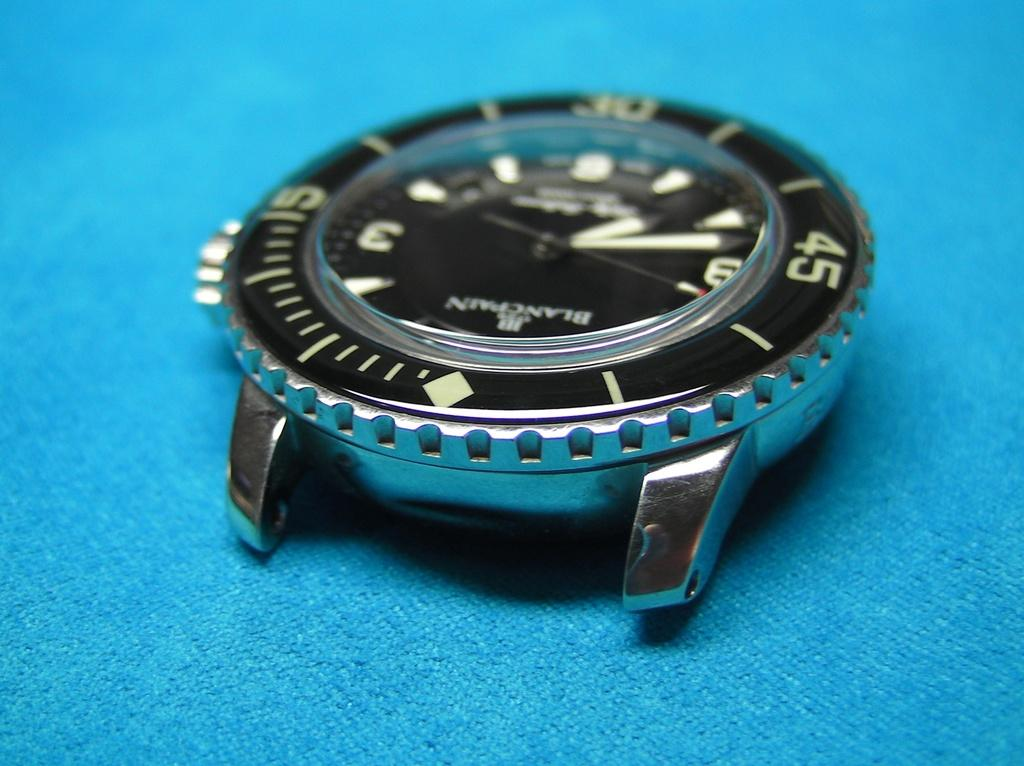<image>
Create a compact narrative representing the image presented. A watch without a wrist band has 5 on the left side of the rim and 45 on the right. side of the rim. 